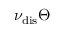Convert formula to latex. <formula><loc_0><loc_0><loc_500><loc_500>\nu _ { d i s } \Theta</formula> 